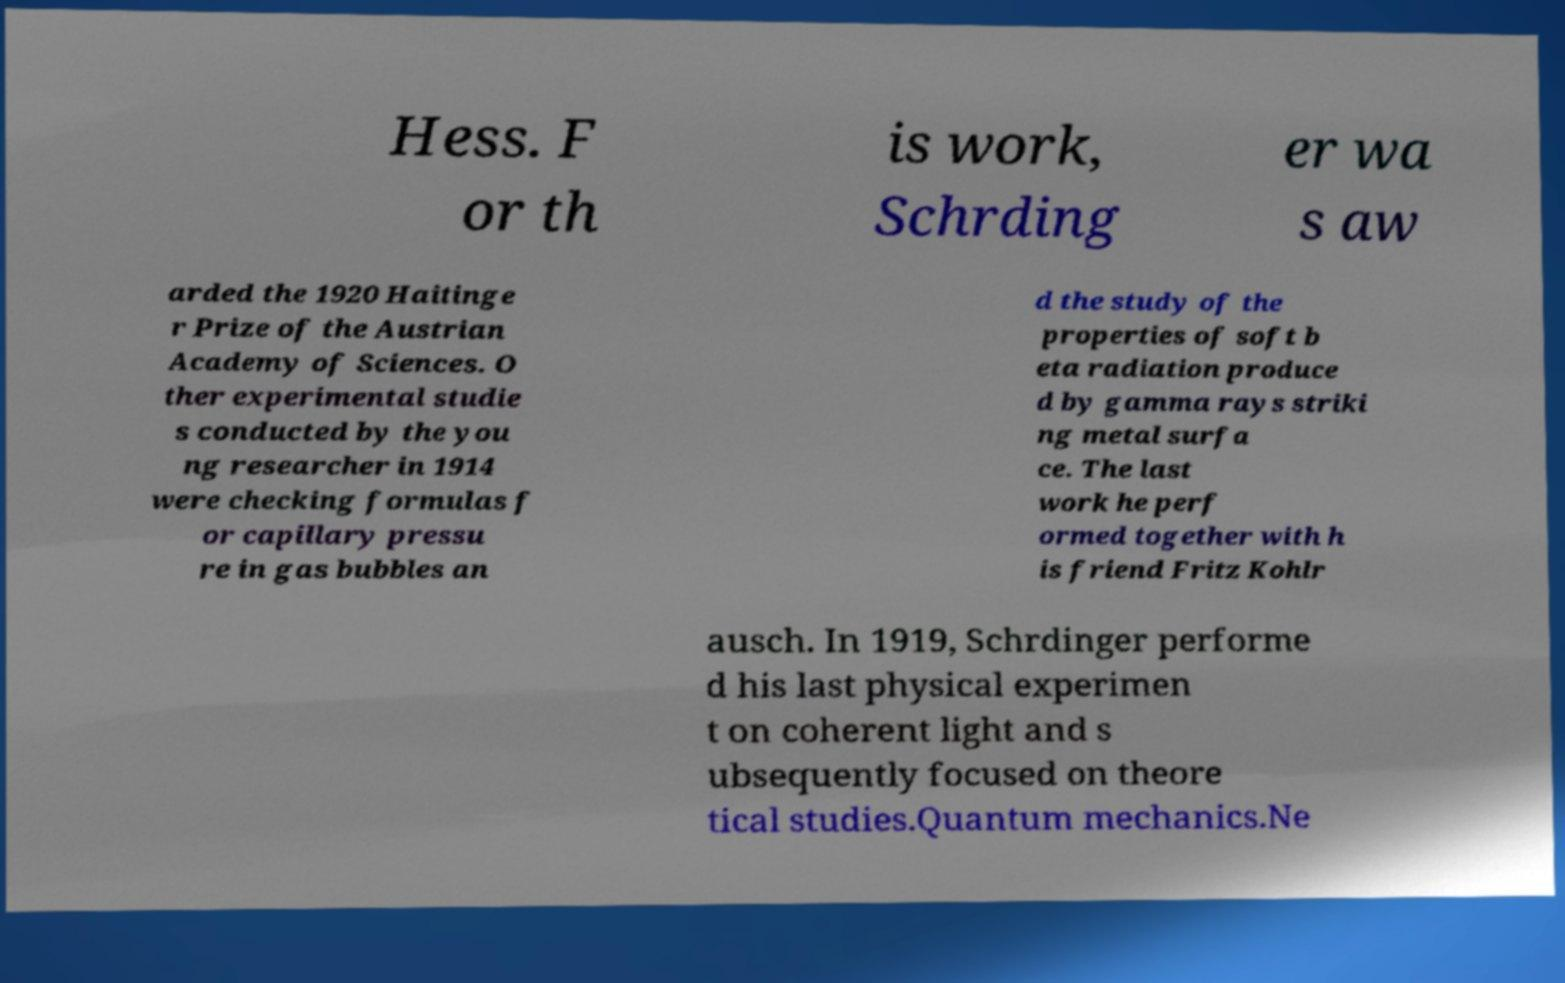Could you extract and type out the text from this image? Hess. F or th is work, Schrding er wa s aw arded the 1920 Haitinge r Prize of the Austrian Academy of Sciences. O ther experimental studie s conducted by the you ng researcher in 1914 were checking formulas f or capillary pressu re in gas bubbles an d the study of the properties of soft b eta radiation produce d by gamma rays striki ng metal surfa ce. The last work he perf ormed together with h is friend Fritz Kohlr ausch. In 1919, Schrdinger performe d his last physical experimen t on coherent light and s ubsequently focused on theore tical studies.Quantum mechanics.Ne 